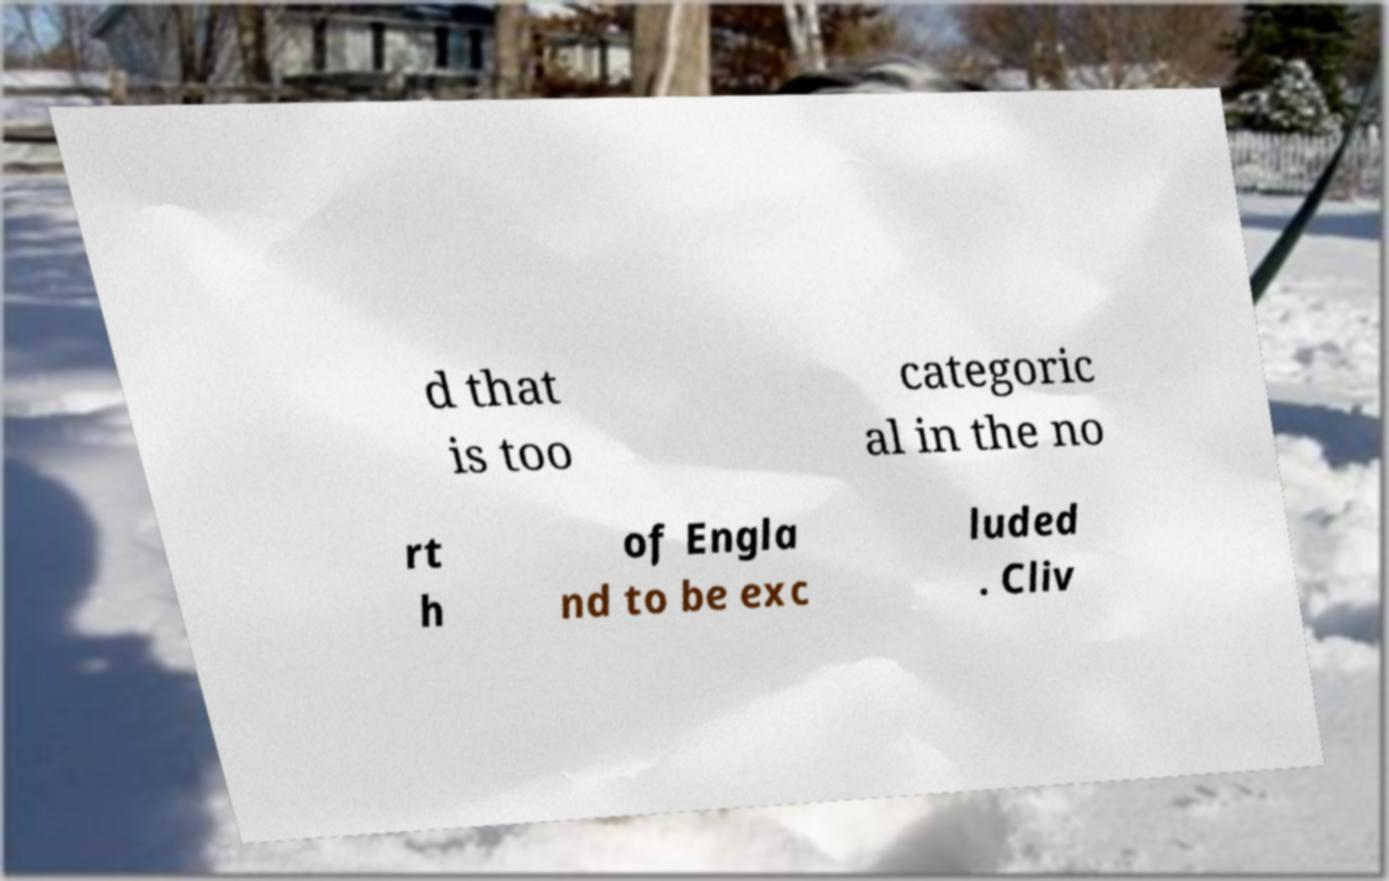Can you accurately transcribe the text from the provided image for me? d that is too categoric al in the no rt h of Engla nd to be exc luded . Cliv 